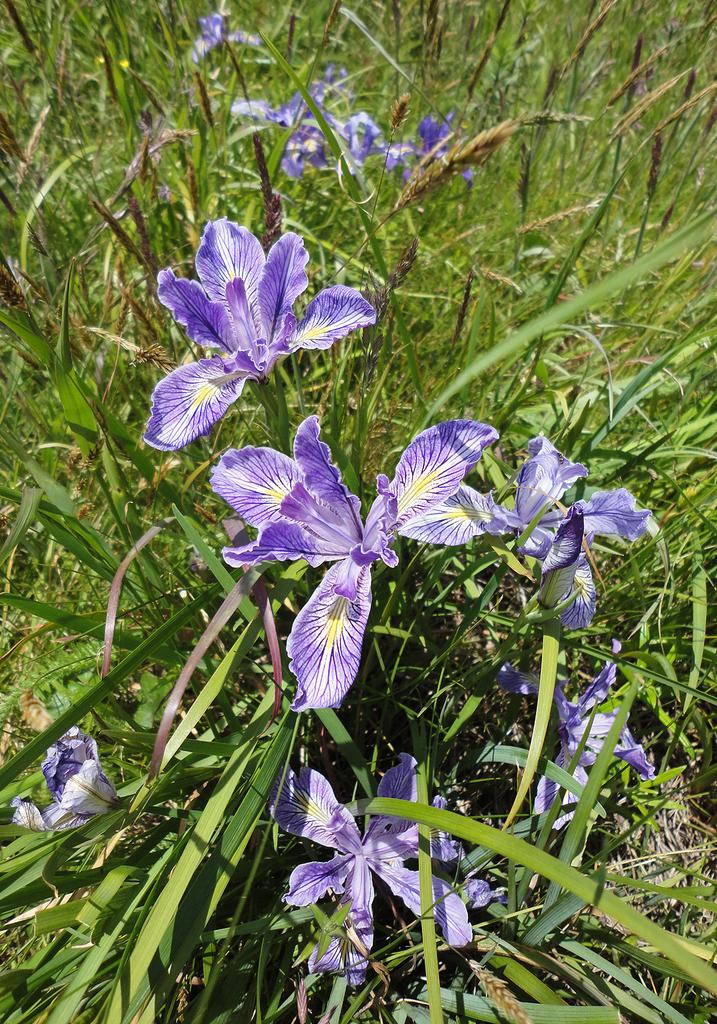What colors are the flowers in the image? The flowers in the image are in purple and white colors. What other elements can be seen in the image besides the flowers? There are plants in green color in the image. What type of stitch is used to create the authority in the image? There is no stitch or authority present in the image; it features flowers and plants. How can the plants be seen playing in the image? The plants do not play in the image; they are stationary and simply depicted as part of the scene. 